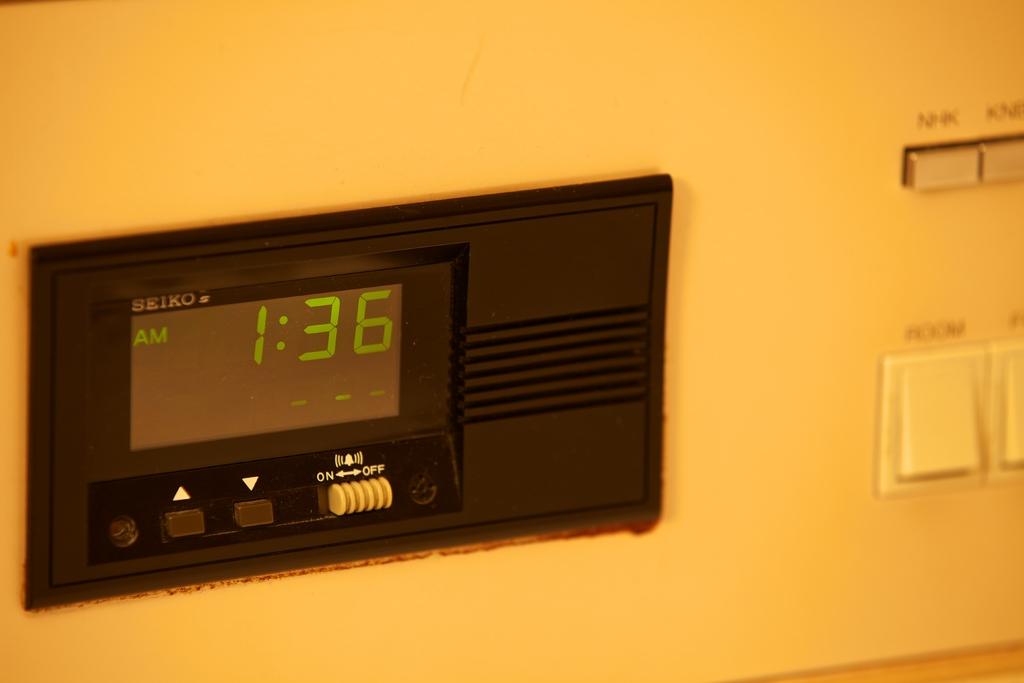Who made the clock?
Ensure brevity in your answer.  Seiko. 